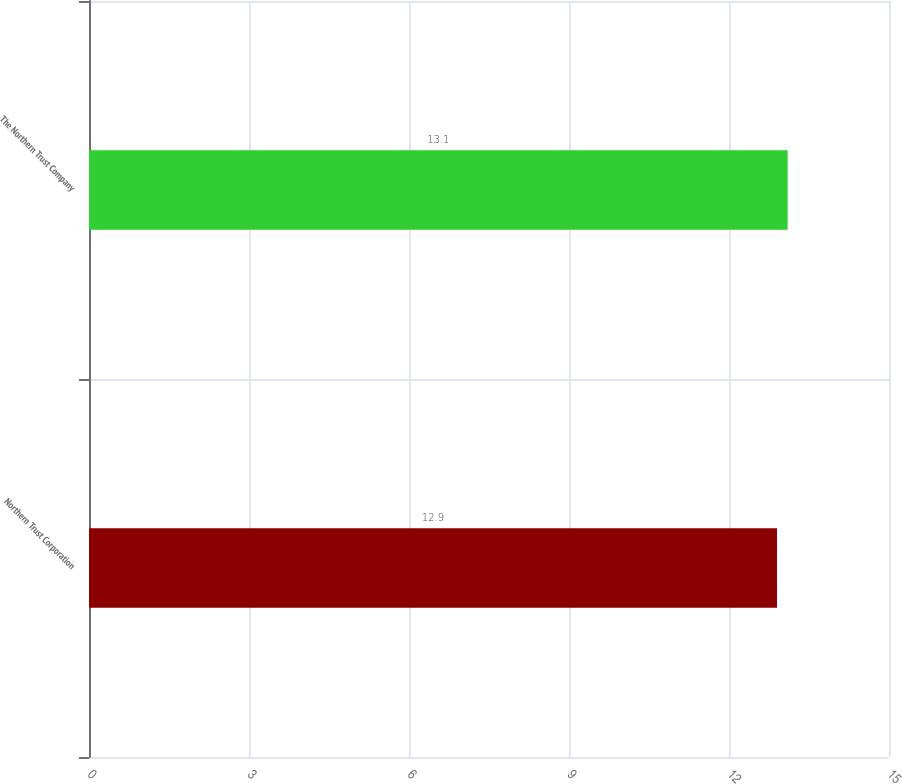Convert chart. <chart><loc_0><loc_0><loc_500><loc_500><bar_chart><fcel>Northern Trust Corporation<fcel>The Northern Trust Company<nl><fcel>12.9<fcel>13.1<nl></chart> 